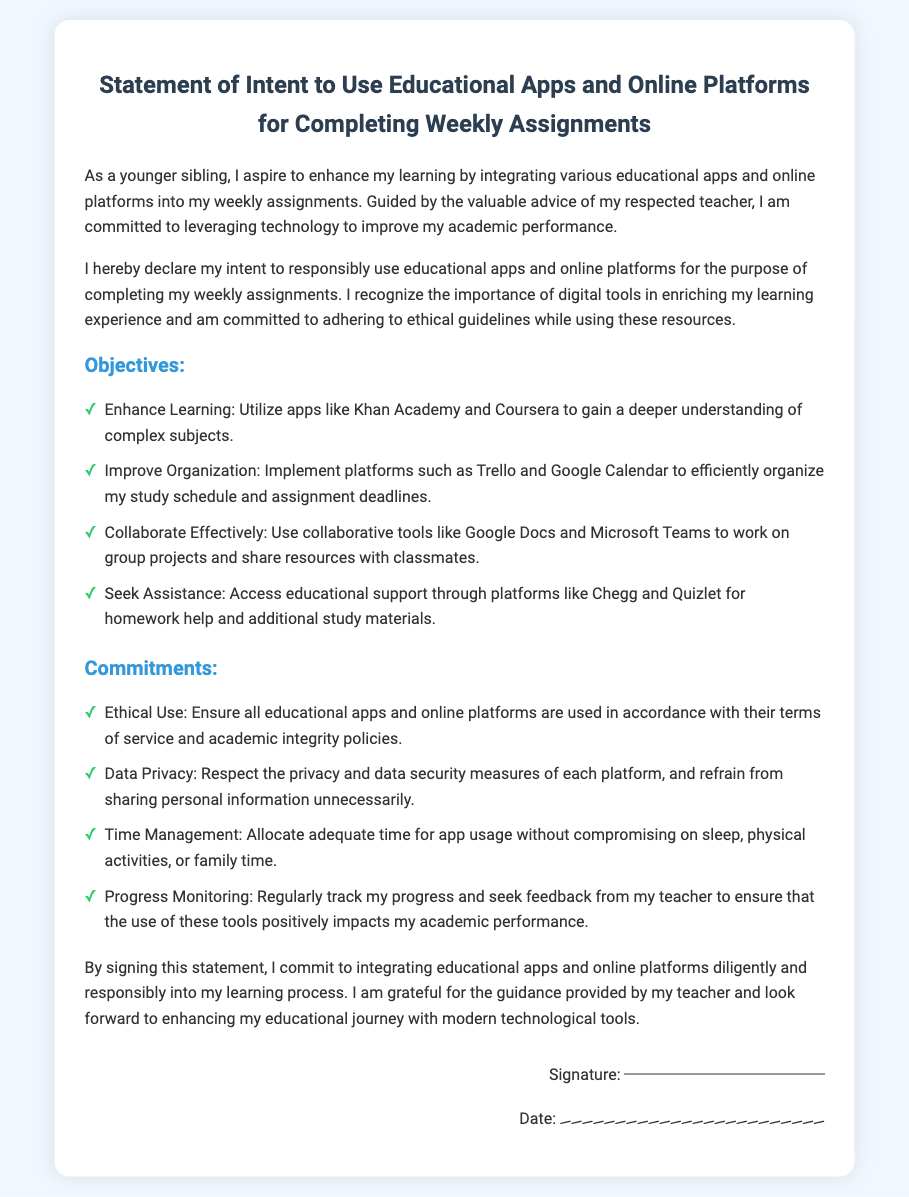what is the title of the document? The title of the document is prominently displayed at the top of the rendered page.
Answer: Statement of Intent to Use Educational Apps and Online Platforms for Completing Weekly Assignments who is the intended user of the educational apps? The document states that the user is a younger sibling, as specified in the introduction.
Answer: younger sibling what is one app mentioned for enhancing learning? The document lists specific apps in the objectives section, highlighting their intended use.
Answer: Khan Academy what commitment is made regarding data privacy? The commitments are clearly outlined in a list that includes the user's pledge about data privacy.
Answer: Respect the privacy and data security measures how many objectives are outlined in the document? The document enumerates the objectives in a list format, providing a count of the items.
Answer: four which tool is suggested for improving organization? The document mentions a specific platform designed to help in organizing tasks.
Answer: Trello what should the user regularly track according to the commitments? The commitments section in the document specifies an element that should be monitored.
Answer: progress what is required at the end of the document to finalize the statement? The closing section details a formal requirement to complete the document to make it official.
Answer: Signature 